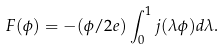Convert formula to latex. <formula><loc_0><loc_0><loc_500><loc_500>F ( \phi ) = - ( \phi / 2 e ) \int _ { 0 } ^ { 1 } j ( \lambda \phi ) d \lambda .</formula> 